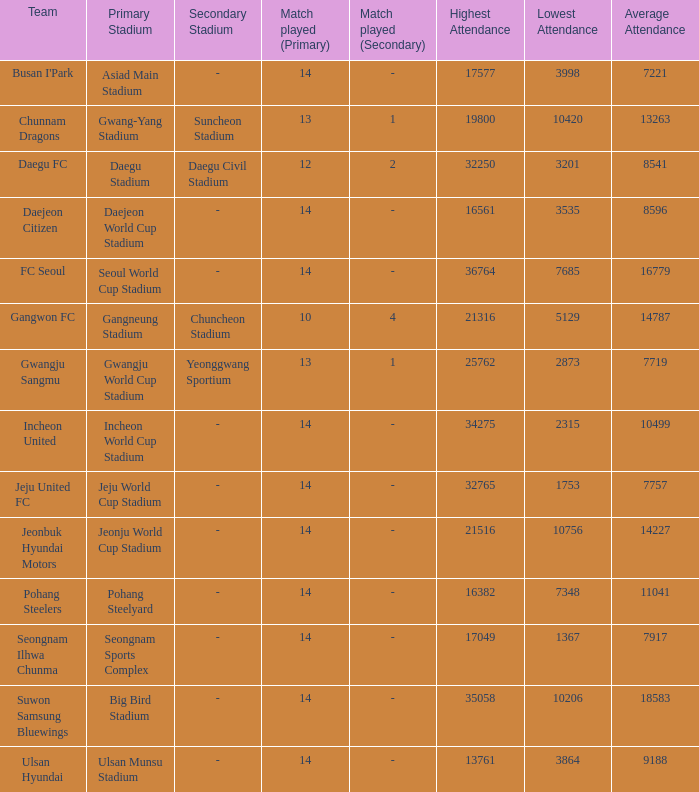What is the lowest when pohang steelyard is the stadium? 7348.0. 